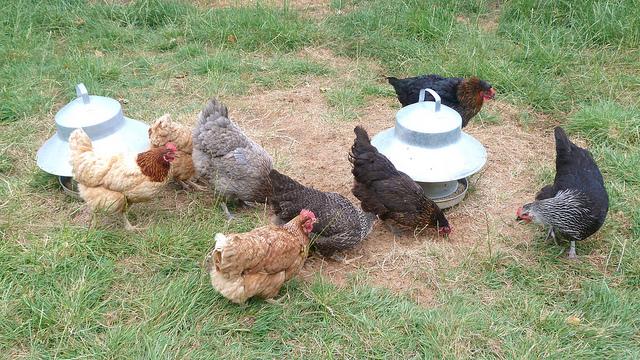Are the chickens fighting with one another?
Be succinct. No. How many roosters are eating?
Be succinct. 0. How many brown chickens seen?
Answer briefly. 3. 